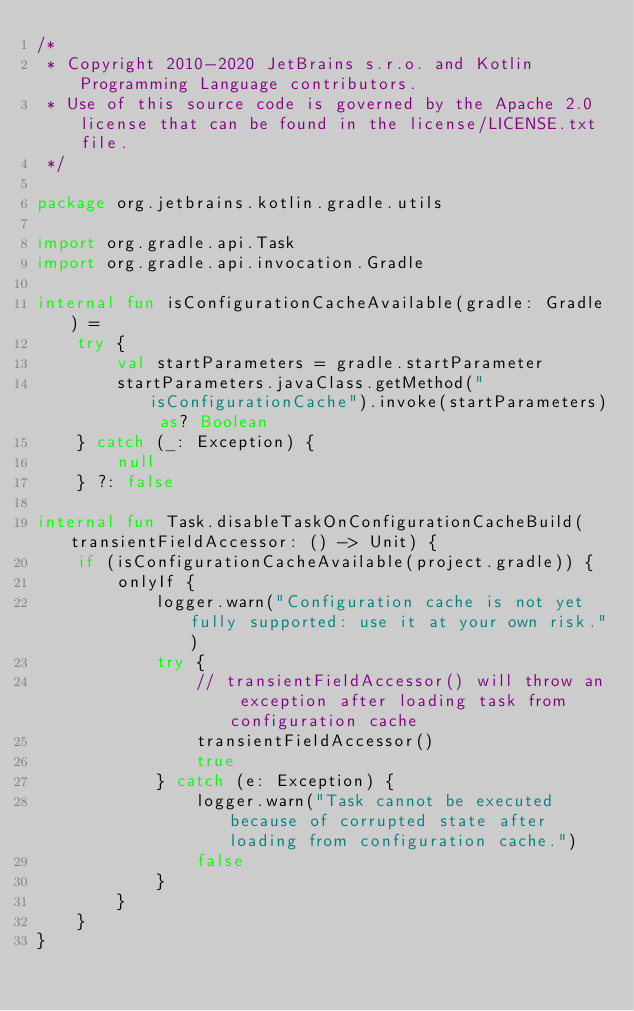Convert code to text. <code><loc_0><loc_0><loc_500><loc_500><_Kotlin_>/*
 * Copyright 2010-2020 JetBrains s.r.o. and Kotlin Programming Language contributors.
 * Use of this source code is governed by the Apache 2.0 license that can be found in the license/LICENSE.txt file.
 */

package org.jetbrains.kotlin.gradle.utils

import org.gradle.api.Task
import org.gradle.api.invocation.Gradle

internal fun isConfigurationCacheAvailable(gradle: Gradle) =
    try {
        val startParameters = gradle.startParameter
        startParameters.javaClass.getMethod("isConfigurationCache").invoke(startParameters) as? Boolean
    } catch (_: Exception) {
        null
    } ?: false

internal fun Task.disableTaskOnConfigurationCacheBuild(transientFieldAccessor: () -> Unit) {
    if (isConfigurationCacheAvailable(project.gradle)) {
        onlyIf {
            logger.warn("Configuration cache is not yet fully supported: use it at your own risk.")
            try {
                // transientFieldAccessor() will throw an exception after loading task from configuration cache
                transientFieldAccessor()
                true
            } catch (e: Exception) {
                logger.warn("Task cannot be executed because of corrupted state after loading from configuration cache.")
                false
            }
        }
    }
}</code> 